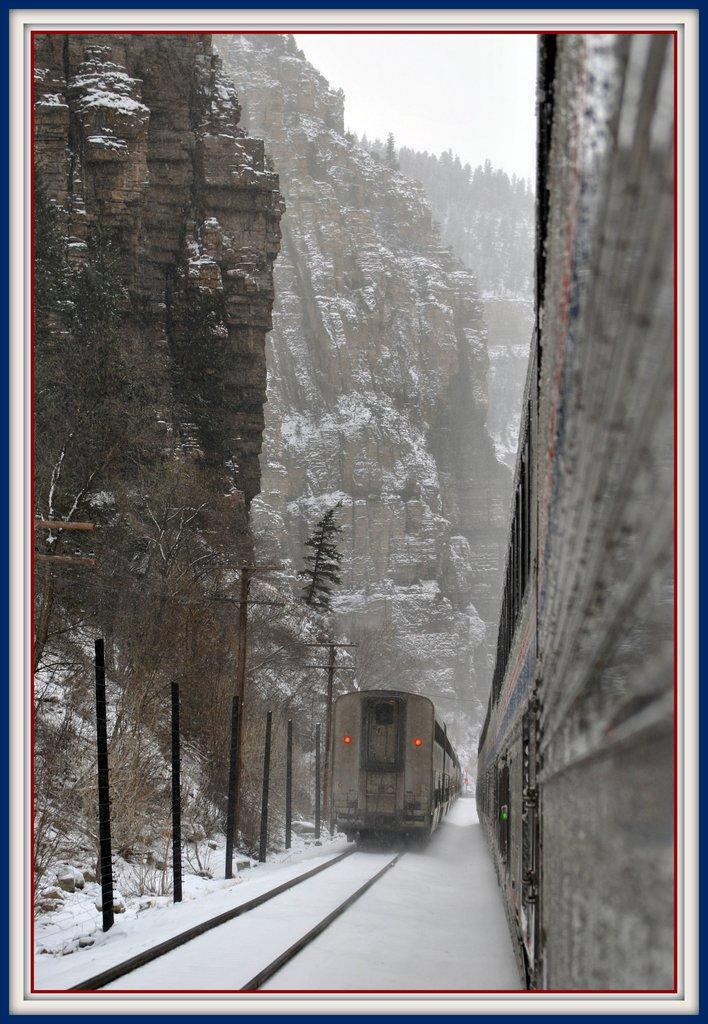What is the color scheme of the image? The image is black and white. What can be seen on the railway tracks? There are trains on the railway tracks. How is the railway affected by the weather? The railway tracks are covered with snow. What is the geographical setting of the scene? The scene is surrounded by mountains. What type of vegetation is present in the scene? Trees are present in the scene. What structures can be seen in the scene? Poles are visible in the scene. What type of cakes are being served at the division in the image? There is no division or cakes present in the image; it features a black and white scene of trains on snow-covered railway tracks surrounded by mountains. 